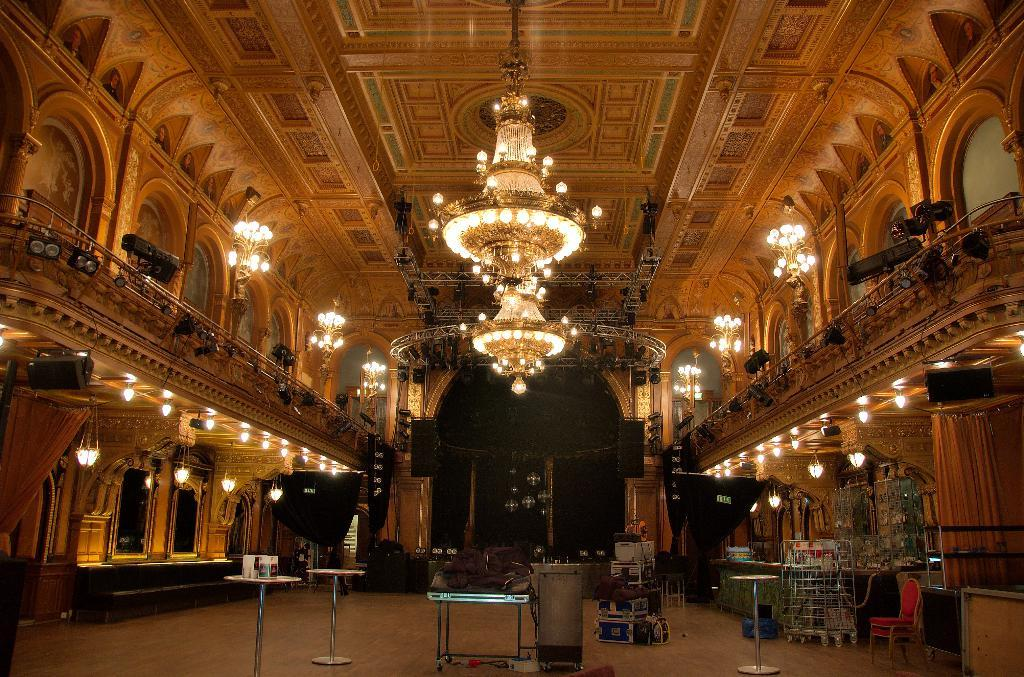What type of lighting fixtures can be seen in the image? There are chandeliers and lights in the image. What architectural feature is present in the image? There are railings in the image. What type of audio equipment is visible in the image? There are speakers in the image. What type of window treatment is present in the image? There are curtains in the image. What type of furniture is present in the image? There are tables and chairs in the image. What type of surface is visible in the image? There is a floor visible in the image. What else can be seen in the image besides the mentioned items? There are objects in the image. What type of shoe can be seen on the floor in the image? There is no shoe present on the floor in the image. What type of precipitation is falling in the image? There is no precipitation visible in the image. 